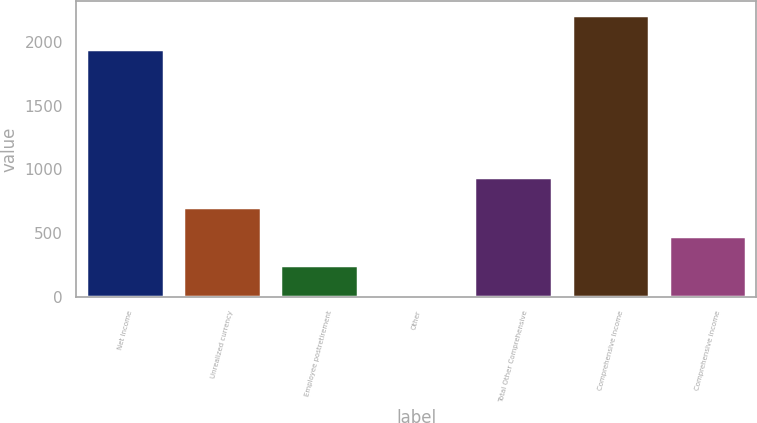Convert chart. <chart><loc_0><loc_0><loc_500><loc_500><bar_chart><fcel>Net Income<fcel>Unrealized currency<fcel>Employee postretirement<fcel>Other<fcel>Total Other Comprehensive<fcel>Comprehensive Income<fcel>Comprehensive income<nl><fcel>1943<fcel>706<fcel>246<fcel>16<fcel>936<fcel>2210<fcel>476<nl></chart> 